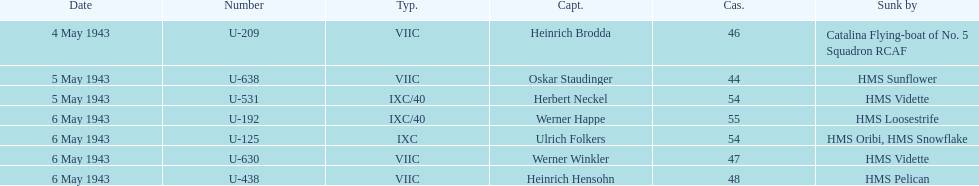Which date had at least 55 casualties? 6 May 1943. 